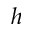Convert formula to latex. <formula><loc_0><loc_0><loc_500><loc_500>h</formula> 